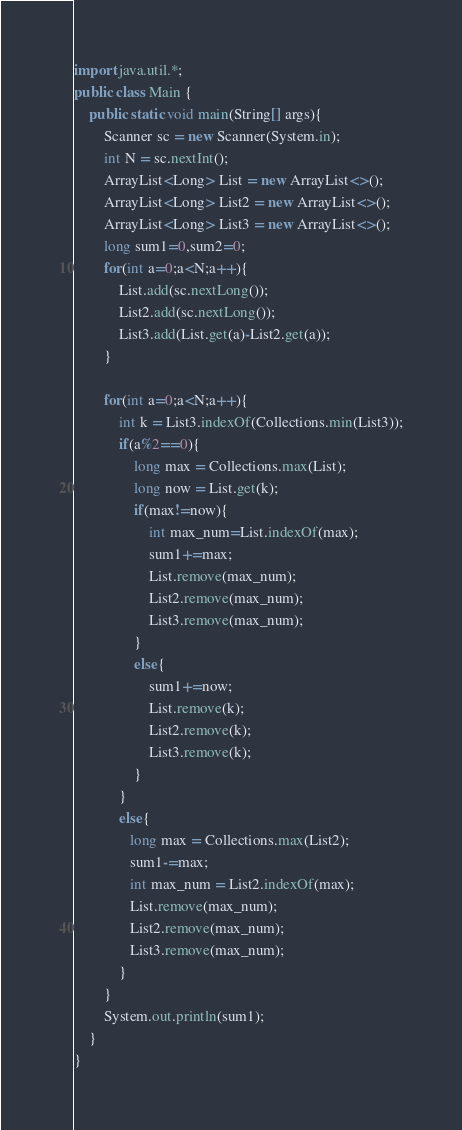<code> <loc_0><loc_0><loc_500><loc_500><_Java_>import java.util.*;
public class Main {
    public static void main(String[] args){
        Scanner sc = new Scanner(System.in);
        int N = sc.nextInt();
        ArrayList<Long> List = new ArrayList<>();
        ArrayList<Long> List2 = new ArrayList<>();
        ArrayList<Long> List3 = new ArrayList<>();
        long sum1=0,sum2=0;
        for(int a=0;a<N;a++){
            List.add(sc.nextLong());
            List2.add(sc.nextLong());
            List3.add(List.get(a)-List2.get(a));
        }

        for(int a=0;a<N;a++){
            int k = List3.indexOf(Collections.min(List3));
            if(a%2==0){
                long max = Collections.max(List);
                long now = List.get(k);
                if(max!=now){
                    int max_num=List.indexOf(max);
                    sum1+=max;
                    List.remove(max_num);
                    List2.remove(max_num);
                    List3.remove(max_num);
                }
                else{
                    sum1+=now;
                    List.remove(k);
                    List2.remove(k);
                    List3.remove(k);
                }
            }
            else{
               long max = Collections.max(List2);
               sum1-=max;
               int max_num = List2.indexOf(max);
               List.remove(max_num);
               List2.remove(max_num);
               List3.remove(max_num);
            }
        }
        System.out.println(sum1);
    }
}
</code> 